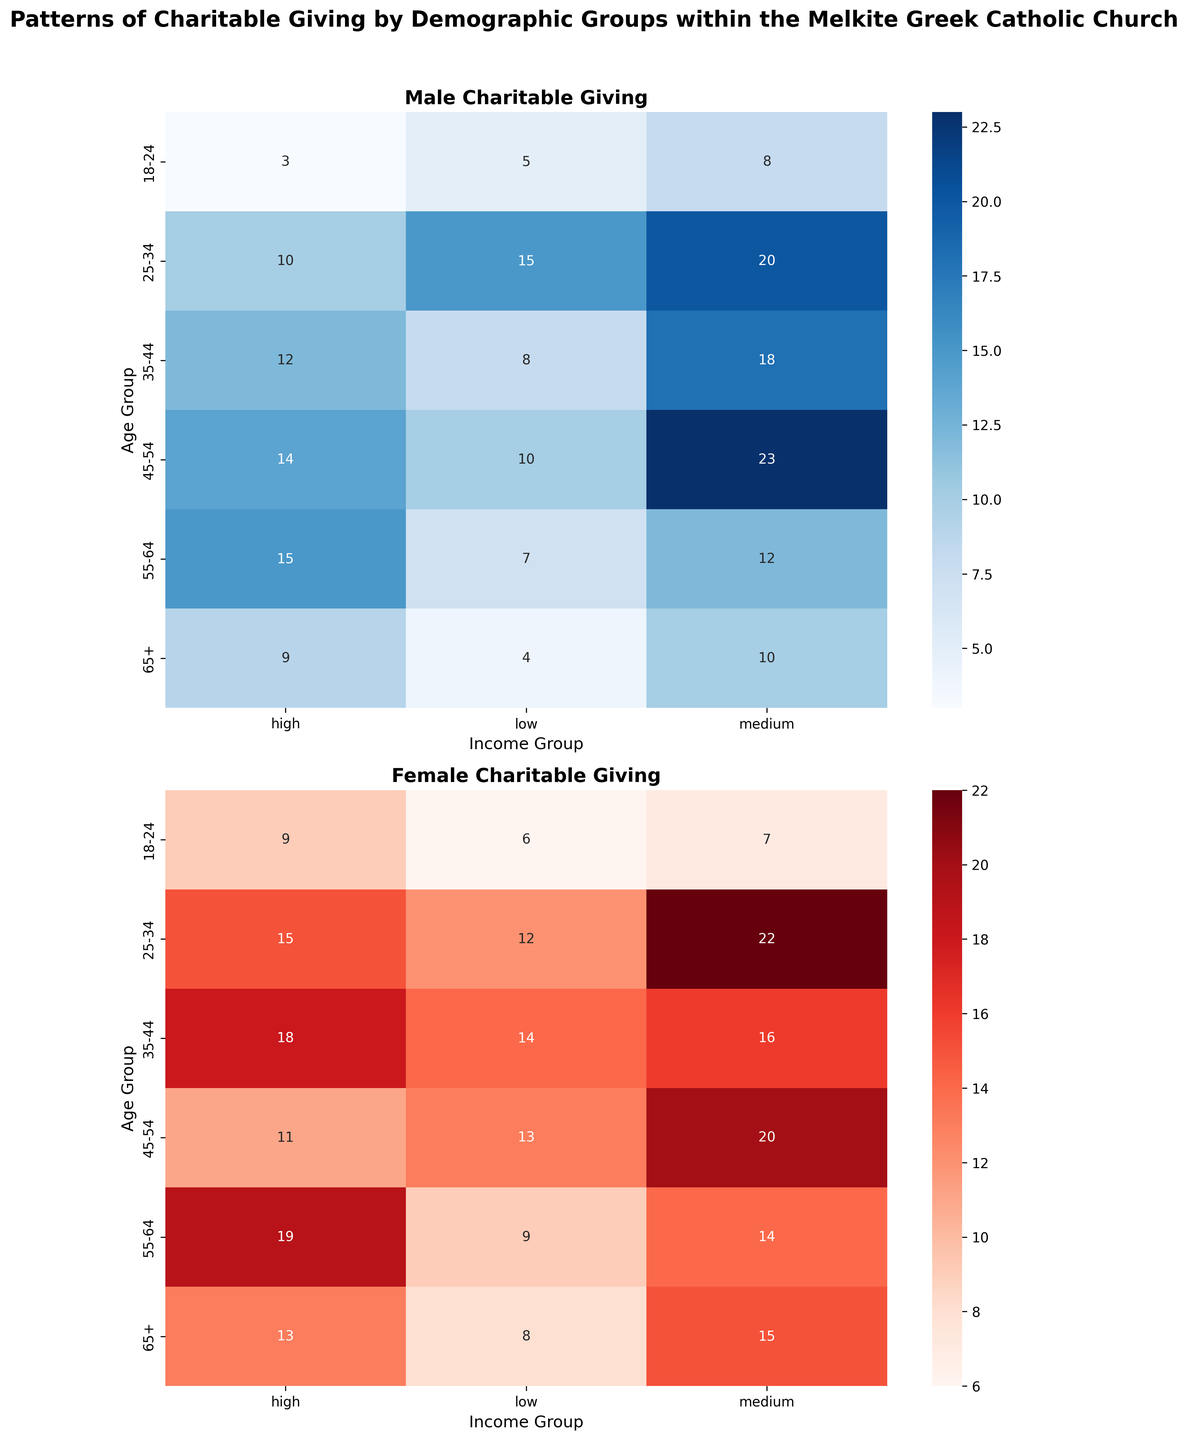Which age group and income group have the highest charitable giving for males? Look at the heatmap for males (blue) and identify the cell with the highest number. It is in the age group 45-54 and income group medium, with a value of 23.
Answer: 45-54, medium How does the charitable giving of 25-34 year old males compare between low and high income groups? For the 25-34 age group, the male charitable giving is 15 in the low-income group and 10 in the high-income group. 15 is greater than 10.
Answer: 25-34 year old males give more in the low-income group than in the high-income group What is the total number of charitable givers in the 35-44 age group? Sum all the values for the 35-44 age group for both males and females from the heatmap. The males contribute (8 + 18 + 12 = 38) and the females contribute (14 + 16 + 18 = 48). So the total is 38 + 48 = 86.
Answer: 86 Which gender has higher charitable giving in the high-income group for the 65+ age group? In the high-income group for the 65+ age group, male giving is 9 and female giving is 13. Since 13 is greater than 9, females give more.
Answer: Females What is the average number of charitable givers for males in the medium-income group across all age groups? Add up the values for males in the medium-income group across all age groups (8 + 20 + 18 + 23 + 12 + 10) which equals 91, and then divide by the number of age categories, which is 6. So 91 / 6 ≈ 15.17.
Answer: 15.17 In the male demographic, which age and income group has the lowest number of charitable givers? Look at the heatmap for males and find the cell with the lowest value. It is the 18-24 age group and high-income group with a value of 3.
Answer: 18-24, high Which income group shows the largest difference in charitable giving between males and females in the 45-54 age group? For 45-54 age group, calculate the differences between males and females for each income group: low (10 vs 13: difference = 3), medium (23 vs 20: difference = 3), high (14 vs 11: difference = 3). All differences are equal to 3.
Answer: All income groups have the same difference If we combine the medium-income group across all age groups, which gender has a higher total charitable giving? Sum the values in the medium-income group for both males and females: Male (8 + 20 + 18 + 23 + 12 + 10 = 91), Female (7 + 22 + 16 + 20 + 14 + 15 = 94). Since 94 is greater than 91, females give more in total.
Answer: Females 